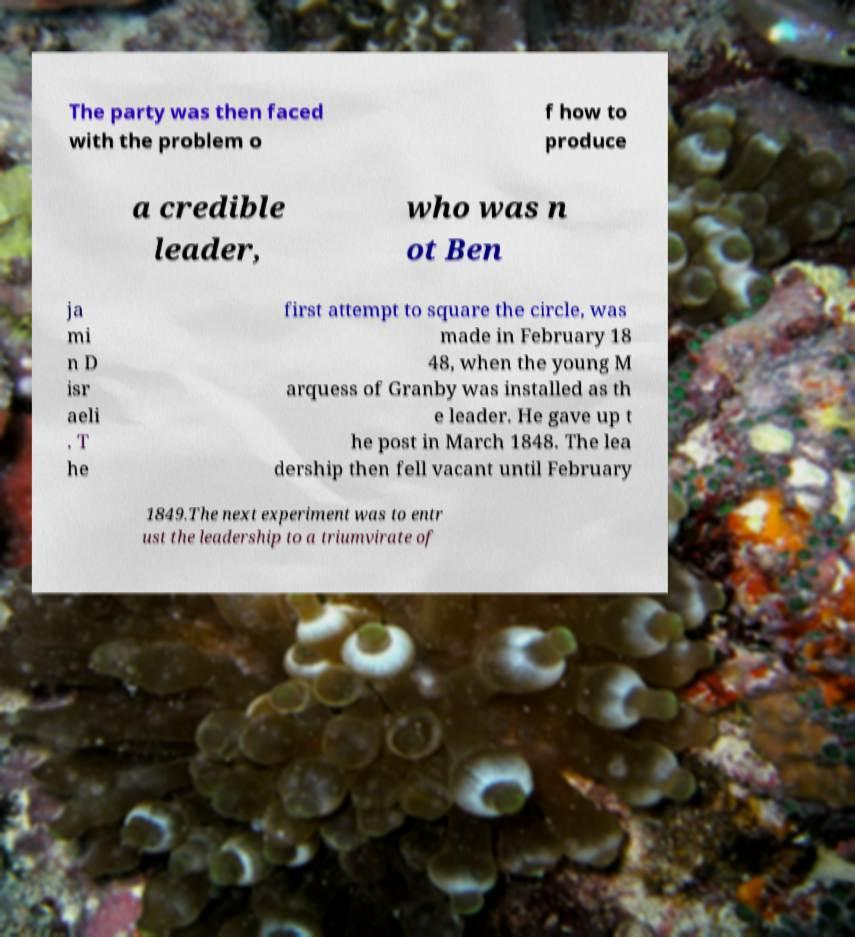For documentation purposes, I need the text within this image transcribed. Could you provide that? The party was then faced with the problem o f how to produce a credible leader, who was n ot Ben ja mi n D isr aeli . T he first attempt to square the circle, was made in February 18 48, when the young M arquess of Granby was installed as th e leader. He gave up t he post in March 1848. The lea dership then fell vacant until February 1849.The next experiment was to entr ust the leadership to a triumvirate of 